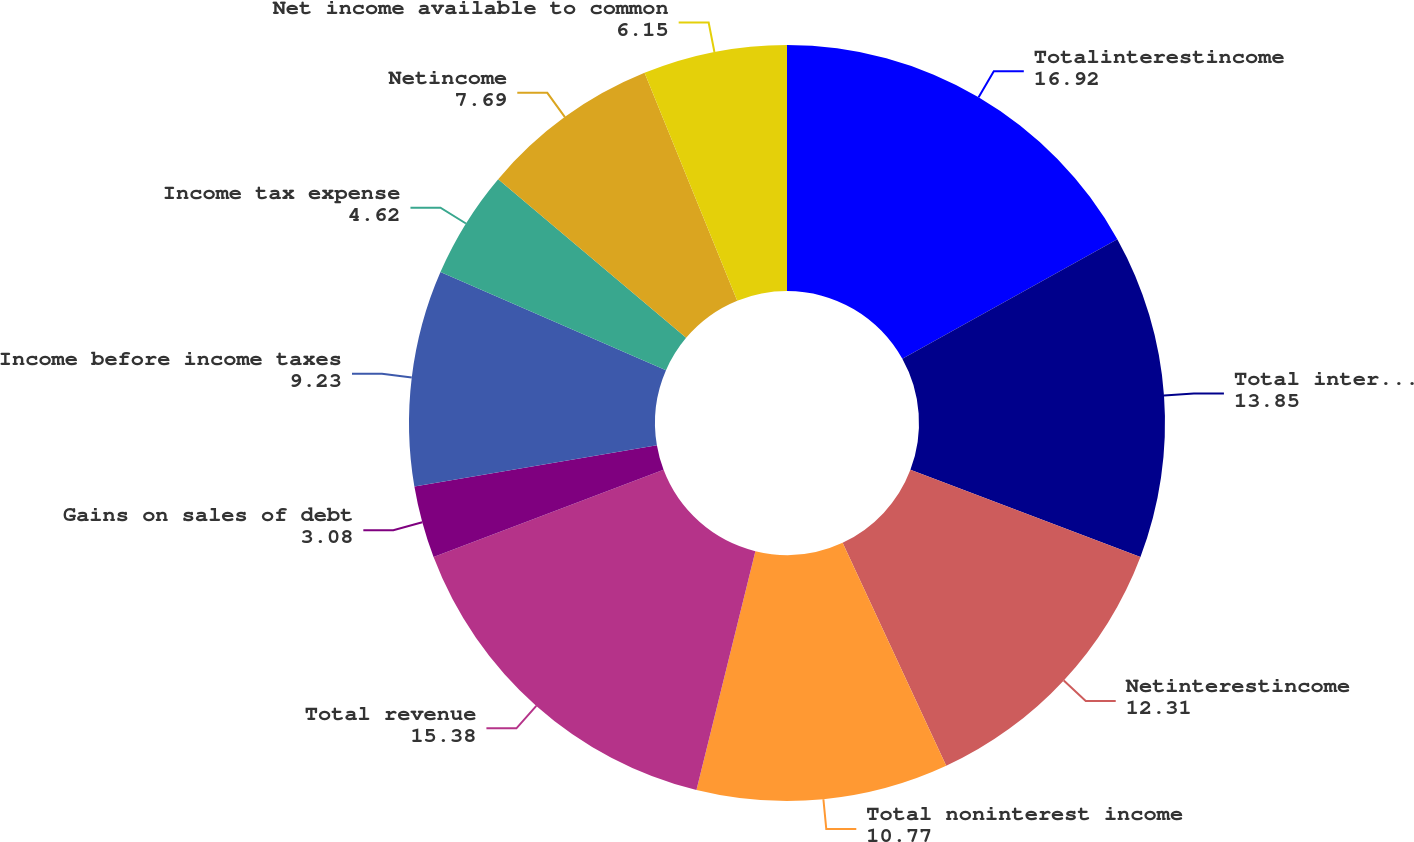<chart> <loc_0><loc_0><loc_500><loc_500><pie_chart><fcel>Totalinterestincome<fcel>Total interest expense<fcel>Netinterestincome<fcel>Total noninterest income<fcel>Total revenue<fcel>Gains on sales of debt<fcel>Income before income taxes<fcel>Income tax expense<fcel>Netincome<fcel>Net income available to common<nl><fcel>16.92%<fcel>13.85%<fcel>12.31%<fcel>10.77%<fcel>15.38%<fcel>3.08%<fcel>9.23%<fcel>4.62%<fcel>7.69%<fcel>6.15%<nl></chart> 